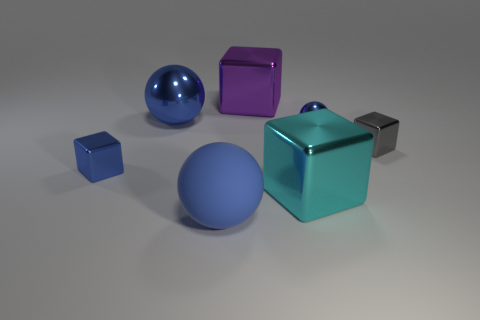Is there a blue metal thing that has the same shape as the large purple object?
Keep it short and to the point. Yes. There is a big ball that is the same color as the matte object; what is its material?
Ensure brevity in your answer.  Metal. What shape is the small shiny object to the left of the big blue matte thing?
Your response must be concise. Cube. How many blue shiny cubes are there?
Make the answer very short. 1. There is a tiny sphere that is the same material as the cyan block; what is its color?
Offer a terse response. Blue. What number of tiny objects are yellow cylinders or shiny objects?
Ensure brevity in your answer.  3. There is a tiny blue cube; what number of blue matte objects are in front of it?
Your answer should be very brief. 1. There is another tiny metallic thing that is the same shape as the gray object; what color is it?
Your response must be concise. Blue. How many matte things are large blocks or small purple cylinders?
Provide a succinct answer. 0. Is there a small sphere that is behind the block that is on the left side of the large cube behind the gray block?
Give a very brief answer. Yes. 